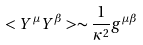Convert formula to latex. <formula><loc_0><loc_0><loc_500><loc_500>< Y ^ { \mu } Y ^ { \beta } > \sim \frac { 1 } { \kappa ^ { 2 } } g ^ { \mu \beta }</formula> 